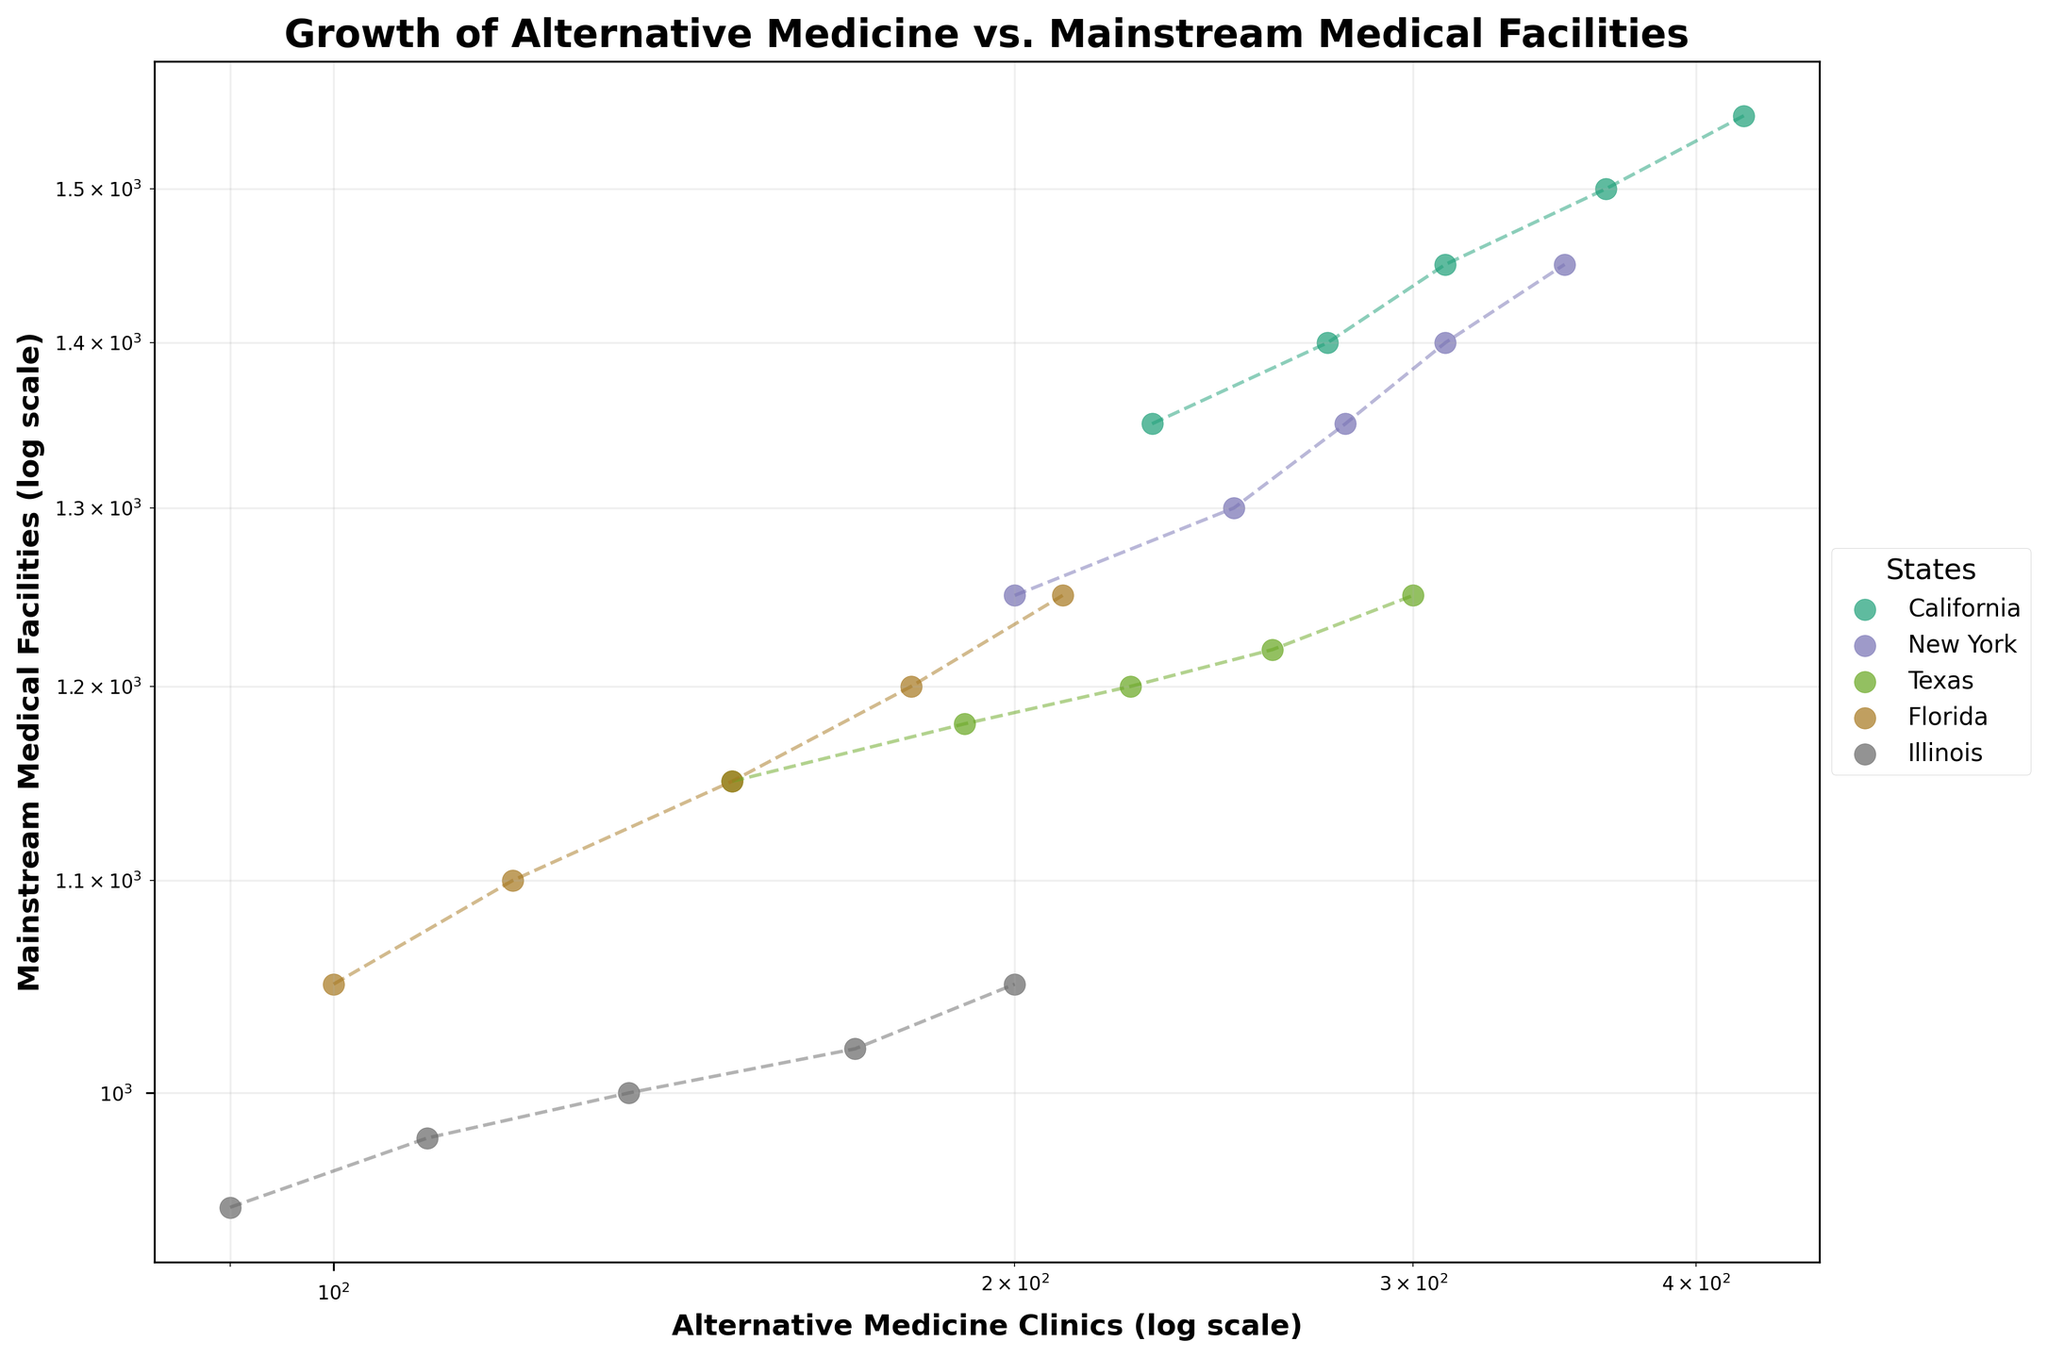How many states are represented in the figure? The figure includes data points with distinct colors for each state. By counting the number of unique colors and labels in the legend, we can determine the number of states represented. There are five colors/labels in the legend, indicating five states.
Answer: 5 What is the title of the figure? The title of the figure can be found at the top of the plot. It is displayed in bold and larger font than the rest of the text.
Answer: Growth of Alternative Medicine vs. Mainstream Medical Facilities Which state shows the steepest increase in Alternative Medicine Clinics from 2017 to 2021? To determine the steepest increase, we need to look at the slope of the line connecting the data points for each state from 2017 to 2021. In a log-log scale, steeper increases appear as higher slopes. California shows the steepest increase as the separation between its data points is the largest.
Answer: California What is the range of the number of Alternative Medicine Clinics in New York from 2017 to 2021? To find the range, we locate the smallest and largest data points for New York on the x-axis (Alternative Medicine Clinics). For New York, the clinics range from 200 (2017) to 350 (2021). The difference is the range.
Answer: 150 By looking at the year 2019, which state has more Mainstream Medical Facilities: Texas or Florida? To answer this, we need to compare the y-axis values (Mainstream Medical Facilities) for both Texas and Florida in 2019. Texas in 2019 has about 1200 facilities, whereas Florida has approximately 1150 facilities.
Answer: Texas In which state do Alternative Medicine Clinics and Mainstream Medical Facilities grow proportionally, maintaining a similar ratio throughout 2017 to 2021? A state where both Alternative Medicine Clinics and Mainstream Medical Facilities grow proportionally will appear on the plot with lines that maintain a consistent ratio. Texas shows a roughly proportional growth in both types of facilities over the years.
Answer: Texas How does the growth trend for Mainstream Medical Facilities in Illinois from 2017 to 2021 compare to California? To compare, we look at the slope of the line connecting the data points for Mainstream Medical Facilities on the y-axis for both states. Illinois shows a gradual increase in facilities, whereas California shows a consistently higher number and also an increase, but less steep compared to Illinois.
Answer: Illinois slower than California 